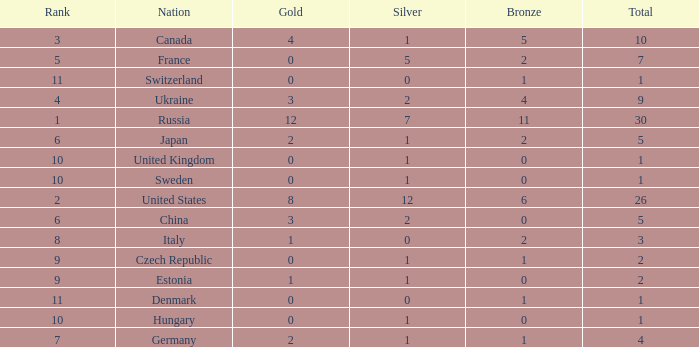What is the largest silver with Gold larger than 4, a Nation of united states, and a Total larger than 26? None. 